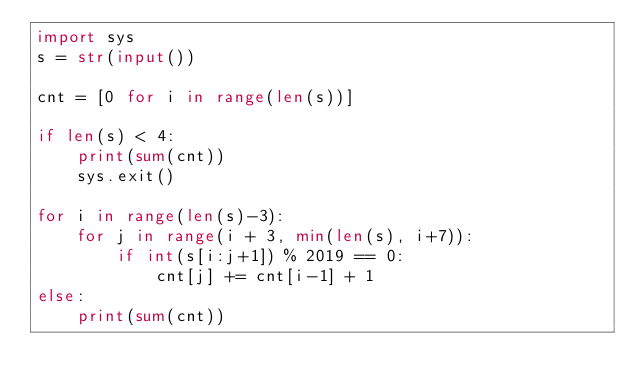<code> <loc_0><loc_0><loc_500><loc_500><_Python_>import sys
s = str(input())

cnt = [0 for i in range(len(s))]

if len(s) < 4:
    print(sum(cnt))
    sys.exit()

for i in range(len(s)-3):
    for j in range(i + 3, min(len(s), i+7)):
        if int(s[i:j+1]) % 2019 == 0:
            cnt[j] += cnt[i-1] + 1
else:
    print(sum(cnt))
</code> 